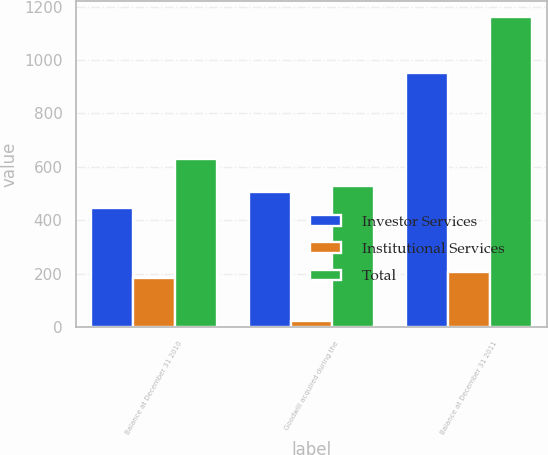<chart> <loc_0><loc_0><loc_500><loc_500><stacked_bar_chart><ecel><fcel>Balance at December 31 2010<fcel>Goodwill acquired during the<fcel>Balance at December 31 2011<nl><fcel>Investor Services<fcel>446<fcel>507<fcel>953<nl><fcel>Institutional Services<fcel>185<fcel>23<fcel>208<nl><fcel>Total<fcel>631<fcel>530<fcel>1161<nl></chart> 